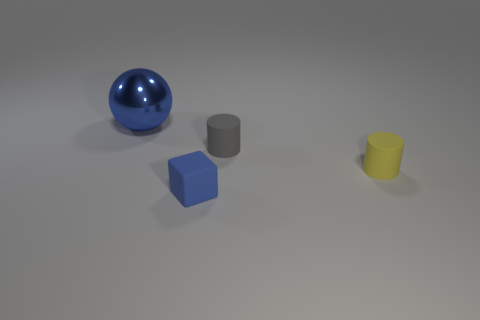Subtract all blocks. How many objects are left? 3 Subtract 1 cubes. How many cubes are left? 0 Subtract all gray cylinders. Subtract all gray balls. How many cylinders are left? 1 Subtract all purple cubes. How many gray cylinders are left? 1 Subtract all large gray rubber cylinders. Subtract all big metallic things. How many objects are left? 3 Add 3 tiny yellow cylinders. How many tiny yellow cylinders are left? 4 Add 3 tiny yellow cylinders. How many tiny yellow cylinders exist? 4 Add 2 small objects. How many objects exist? 6 Subtract 0 green balls. How many objects are left? 4 